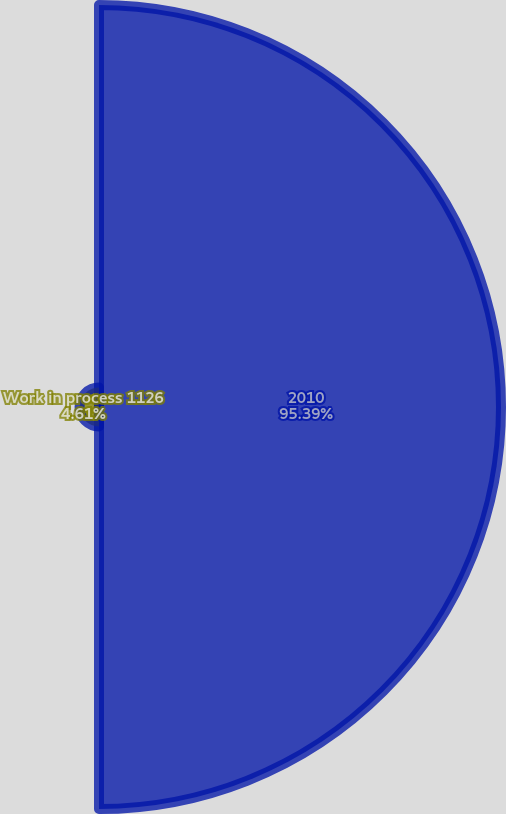Convert chart. <chart><loc_0><loc_0><loc_500><loc_500><pie_chart><fcel>2010<fcel>Work in process 1126<nl><fcel>95.39%<fcel>4.61%<nl></chart> 